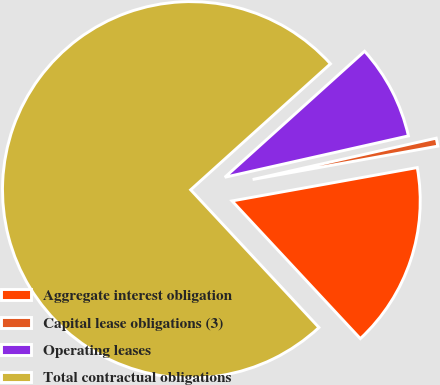<chart> <loc_0><loc_0><loc_500><loc_500><pie_chart><fcel>Aggregate interest obligation<fcel>Capital lease obligations (3)<fcel>Operating leases<fcel>Total contractual obligations<nl><fcel>15.9%<fcel>0.69%<fcel>8.15%<fcel>75.26%<nl></chart> 